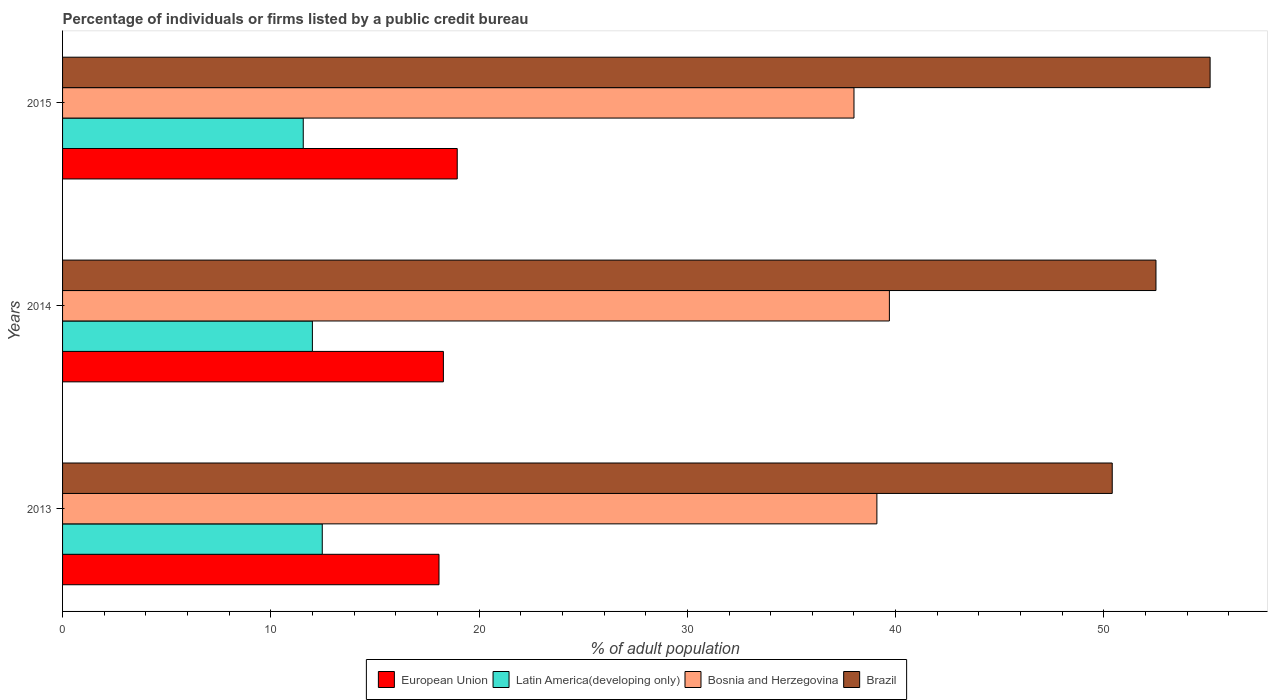How many bars are there on the 3rd tick from the bottom?
Give a very brief answer. 4. What is the percentage of population listed by a public credit bureau in Latin America(developing only) in 2014?
Your answer should be very brief. 12. Across all years, what is the maximum percentage of population listed by a public credit bureau in European Union?
Provide a short and direct response. 18.95. Across all years, what is the minimum percentage of population listed by a public credit bureau in European Union?
Keep it short and to the point. 18.07. In which year was the percentage of population listed by a public credit bureau in European Union maximum?
Your response must be concise. 2015. What is the total percentage of population listed by a public credit bureau in European Union in the graph?
Offer a very short reply. 55.31. What is the difference between the percentage of population listed by a public credit bureau in Bosnia and Herzegovina in 2013 and that in 2015?
Your response must be concise. 1.1. What is the difference between the percentage of population listed by a public credit bureau in European Union in 2014 and the percentage of population listed by a public credit bureau in Latin America(developing only) in 2015?
Offer a very short reply. 6.73. What is the average percentage of population listed by a public credit bureau in European Union per year?
Your answer should be compact. 18.44. In the year 2014, what is the difference between the percentage of population listed by a public credit bureau in Bosnia and Herzegovina and percentage of population listed by a public credit bureau in Latin America(developing only)?
Offer a very short reply. 27.7. In how many years, is the percentage of population listed by a public credit bureau in Bosnia and Herzegovina greater than 28 %?
Ensure brevity in your answer.  3. What is the ratio of the percentage of population listed by a public credit bureau in Bosnia and Herzegovina in 2014 to that in 2015?
Make the answer very short. 1.04. Is the percentage of population listed by a public credit bureau in Bosnia and Herzegovina in 2013 less than that in 2015?
Provide a succinct answer. No. What is the difference between the highest and the second highest percentage of population listed by a public credit bureau in Bosnia and Herzegovina?
Provide a short and direct response. 0.6. What is the difference between the highest and the lowest percentage of population listed by a public credit bureau in Bosnia and Herzegovina?
Ensure brevity in your answer.  1.7. In how many years, is the percentage of population listed by a public credit bureau in Latin America(developing only) greater than the average percentage of population listed by a public credit bureau in Latin America(developing only) taken over all years?
Offer a very short reply. 1. Is it the case that in every year, the sum of the percentage of population listed by a public credit bureau in Bosnia and Herzegovina and percentage of population listed by a public credit bureau in Latin America(developing only) is greater than the sum of percentage of population listed by a public credit bureau in Brazil and percentage of population listed by a public credit bureau in European Union?
Your answer should be very brief. Yes. What does the 4th bar from the top in 2014 represents?
Make the answer very short. European Union. What does the 4th bar from the bottom in 2015 represents?
Ensure brevity in your answer.  Brazil. What is the difference between two consecutive major ticks on the X-axis?
Provide a succinct answer. 10. How many legend labels are there?
Offer a terse response. 4. What is the title of the graph?
Offer a very short reply. Percentage of individuals or firms listed by a public credit bureau. What is the label or title of the X-axis?
Ensure brevity in your answer.  % of adult population. What is the % of adult population of European Union in 2013?
Give a very brief answer. 18.07. What is the % of adult population of Latin America(developing only) in 2013?
Offer a very short reply. 12.47. What is the % of adult population of Bosnia and Herzegovina in 2013?
Your answer should be compact. 39.1. What is the % of adult population of Brazil in 2013?
Your answer should be compact. 50.4. What is the % of adult population in European Union in 2014?
Make the answer very short. 18.29. What is the % of adult population of Latin America(developing only) in 2014?
Ensure brevity in your answer.  12. What is the % of adult population of Bosnia and Herzegovina in 2014?
Give a very brief answer. 39.7. What is the % of adult population of Brazil in 2014?
Your answer should be very brief. 52.5. What is the % of adult population of European Union in 2015?
Your response must be concise. 18.95. What is the % of adult population in Latin America(developing only) in 2015?
Ensure brevity in your answer.  11.56. What is the % of adult population of Brazil in 2015?
Your answer should be very brief. 55.1. Across all years, what is the maximum % of adult population in European Union?
Offer a terse response. 18.95. Across all years, what is the maximum % of adult population in Latin America(developing only)?
Provide a short and direct response. 12.47. Across all years, what is the maximum % of adult population in Bosnia and Herzegovina?
Give a very brief answer. 39.7. Across all years, what is the maximum % of adult population of Brazil?
Provide a succinct answer. 55.1. Across all years, what is the minimum % of adult population of European Union?
Provide a short and direct response. 18.07. Across all years, what is the minimum % of adult population of Latin America(developing only)?
Offer a terse response. 11.56. Across all years, what is the minimum % of adult population in Brazil?
Make the answer very short. 50.4. What is the total % of adult population of European Union in the graph?
Offer a very short reply. 55.31. What is the total % of adult population of Latin America(developing only) in the graph?
Ensure brevity in your answer.  36.02. What is the total % of adult population in Bosnia and Herzegovina in the graph?
Make the answer very short. 116.8. What is the total % of adult population in Brazil in the graph?
Your answer should be very brief. 158. What is the difference between the % of adult population in European Union in 2013 and that in 2014?
Provide a short and direct response. -0.21. What is the difference between the % of adult population in Latin America(developing only) in 2013 and that in 2014?
Keep it short and to the point. 0.47. What is the difference between the % of adult population in European Union in 2013 and that in 2015?
Offer a terse response. -0.88. What is the difference between the % of adult population in Bosnia and Herzegovina in 2013 and that in 2015?
Your answer should be compact. 1.1. What is the difference between the % of adult population of European Union in 2014 and that in 2015?
Keep it short and to the point. -0.66. What is the difference between the % of adult population in Latin America(developing only) in 2014 and that in 2015?
Your answer should be compact. 0.44. What is the difference between the % of adult population of Bosnia and Herzegovina in 2014 and that in 2015?
Offer a very short reply. 1.7. What is the difference between the % of adult population in European Union in 2013 and the % of adult population in Latin America(developing only) in 2014?
Give a very brief answer. 6.08. What is the difference between the % of adult population in European Union in 2013 and the % of adult population in Bosnia and Herzegovina in 2014?
Keep it short and to the point. -21.62. What is the difference between the % of adult population in European Union in 2013 and the % of adult population in Brazil in 2014?
Keep it short and to the point. -34.42. What is the difference between the % of adult population of Latin America(developing only) in 2013 and the % of adult population of Bosnia and Herzegovina in 2014?
Keep it short and to the point. -27.23. What is the difference between the % of adult population of Latin America(developing only) in 2013 and the % of adult population of Brazil in 2014?
Offer a terse response. -40.03. What is the difference between the % of adult population of Bosnia and Herzegovina in 2013 and the % of adult population of Brazil in 2014?
Your answer should be compact. -13.4. What is the difference between the % of adult population in European Union in 2013 and the % of adult population in Latin America(developing only) in 2015?
Ensure brevity in your answer.  6.52. What is the difference between the % of adult population of European Union in 2013 and the % of adult population of Bosnia and Herzegovina in 2015?
Make the answer very short. -19.93. What is the difference between the % of adult population in European Union in 2013 and the % of adult population in Brazil in 2015?
Your answer should be very brief. -37.02. What is the difference between the % of adult population in Latin America(developing only) in 2013 and the % of adult population in Bosnia and Herzegovina in 2015?
Provide a short and direct response. -25.53. What is the difference between the % of adult population in Latin America(developing only) in 2013 and the % of adult population in Brazil in 2015?
Provide a succinct answer. -42.63. What is the difference between the % of adult population of Bosnia and Herzegovina in 2013 and the % of adult population of Brazil in 2015?
Give a very brief answer. -16. What is the difference between the % of adult population of European Union in 2014 and the % of adult population of Latin America(developing only) in 2015?
Your answer should be very brief. 6.73. What is the difference between the % of adult population of European Union in 2014 and the % of adult population of Bosnia and Herzegovina in 2015?
Your answer should be compact. -19.71. What is the difference between the % of adult population in European Union in 2014 and the % of adult population in Brazil in 2015?
Make the answer very short. -36.81. What is the difference between the % of adult population in Latin America(developing only) in 2014 and the % of adult population in Bosnia and Herzegovina in 2015?
Give a very brief answer. -26. What is the difference between the % of adult population in Latin America(developing only) in 2014 and the % of adult population in Brazil in 2015?
Provide a succinct answer. -43.1. What is the difference between the % of adult population in Bosnia and Herzegovina in 2014 and the % of adult population in Brazil in 2015?
Offer a terse response. -15.4. What is the average % of adult population in European Union per year?
Give a very brief answer. 18.44. What is the average % of adult population in Latin America(developing only) per year?
Give a very brief answer. 12.01. What is the average % of adult population in Bosnia and Herzegovina per year?
Your answer should be very brief. 38.93. What is the average % of adult population in Brazil per year?
Offer a terse response. 52.67. In the year 2013, what is the difference between the % of adult population in European Union and % of adult population in Latin America(developing only)?
Offer a terse response. 5.61. In the year 2013, what is the difference between the % of adult population of European Union and % of adult population of Bosnia and Herzegovina?
Keep it short and to the point. -21.02. In the year 2013, what is the difference between the % of adult population of European Union and % of adult population of Brazil?
Your response must be concise. -32.33. In the year 2013, what is the difference between the % of adult population of Latin America(developing only) and % of adult population of Bosnia and Herzegovina?
Your response must be concise. -26.63. In the year 2013, what is the difference between the % of adult population in Latin America(developing only) and % of adult population in Brazil?
Offer a very short reply. -37.93. In the year 2014, what is the difference between the % of adult population in European Union and % of adult population in Latin America(developing only)?
Offer a very short reply. 6.29. In the year 2014, what is the difference between the % of adult population in European Union and % of adult population in Bosnia and Herzegovina?
Give a very brief answer. -21.41. In the year 2014, what is the difference between the % of adult population of European Union and % of adult population of Brazil?
Keep it short and to the point. -34.21. In the year 2014, what is the difference between the % of adult population in Latin America(developing only) and % of adult population in Bosnia and Herzegovina?
Provide a short and direct response. -27.7. In the year 2014, what is the difference between the % of adult population in Latin America(developing only) and % of adult population in Brazil?
Provide a short and direct response. -40.5. In the year 2015, what is the difference between the % of adult population in European Union and % of adult population in Latin America(developing only)?
Give a very brief answer. 7.39. In the year 2015, what is the difference between the % of adult population of European Union and % of adult population of Bosnia and Herzegovina?
Provide a succinct answer. -19.05. In the year 2015, what is the difference between the % of adult population in European Union and % of adult population in Brazil?
Provide a short and direct response. -36.15. In the year 2015, what is the difference between the % of adult population of Latin America(developing only) and % of adult population of Bosnia and Herzegovina?
Your answer should be compact. -26.44. In the year 2015, what is the difference between the % of adult population in Latin America(developing only) and % of adult population in Brazil?
Give a very brief answer. -43.54. In the year 2015, what is the difference between the % of adult population of Bosnia and Herzegovina and % of adult population of Brazil?
Provide a short and direct response. -17.1. What is the ratio of the % of adult population in European Union in 2013 to that in 2014?
Give a very brief answer. 0.99. What is the ratio of the % of adult population of Latin America(developing only) in 2013 to that in 2014?
Offer a very short reply. 1.04. What is the ratio of the % of adult population of Bosnia and Herzegovina in 2013 to that in 2014?
Provide a succinct answer. 0.98. What is the ratio of the % of adult population in Brazil in 2013 to that in 2014?
Keep it short and to the point. 0.96. What is the ratio of the % of adult population of European Union in 2013 to that in 2015?
Offer a very short reply. 0.95. What is the ratio of the % of adult population in Latin America(developing only) in 2013 to that in 2015?
Give a very brief answer. 1.08. What is the ratio of the % of adult population in Bosnia and Herzegovina in 2013 to that in 2015?
Provide a succinct answer. 1.03. What is the ratio of the % of adult population in Brazil in 2013 to that in 2015?
Your response must be concise. 0.91. What is the ratio of the % of adult population in European Union in 2014 to that in 2015?
Keep it short and to the point. 0.96. What is the ratio of the % of adult population in Latin America(developing only) in 2014 to that in 2015?
Make the answer very short. 1.04. What is the ratio of the % of adult population of Bosnia and Herzegovina in 2014 to that in 2015?
Provide a succinct answer. 1.04. What is the ratio of the % of adult population in Brazil in 2014 to that in 2015?
Make the answer very short. 0.95. What is the difference between the highest and the second highest % of adult population in European Union?
Give a very brief answer. 0.66. What is the difference between the highest and the second highest % of adult population in Latin America(developing only)?
Your response must be concise. 0.47. What is the difference between the highest and the second highest % of adult population of Bosnia and Herzegovina?
Offer a very short reply. 0.6. What is the difference between the highest and the second highest % of adult population of Brazil?
Keep it short and to the point. 2.6. What is the difference between the highest and the lowest % of adult population in European Union?
Your answer should be compact. 0.88. What is the difference between the highest and the lowest % of adult population in Latin America(developing only)?
Make the answer very short. 0.91. 